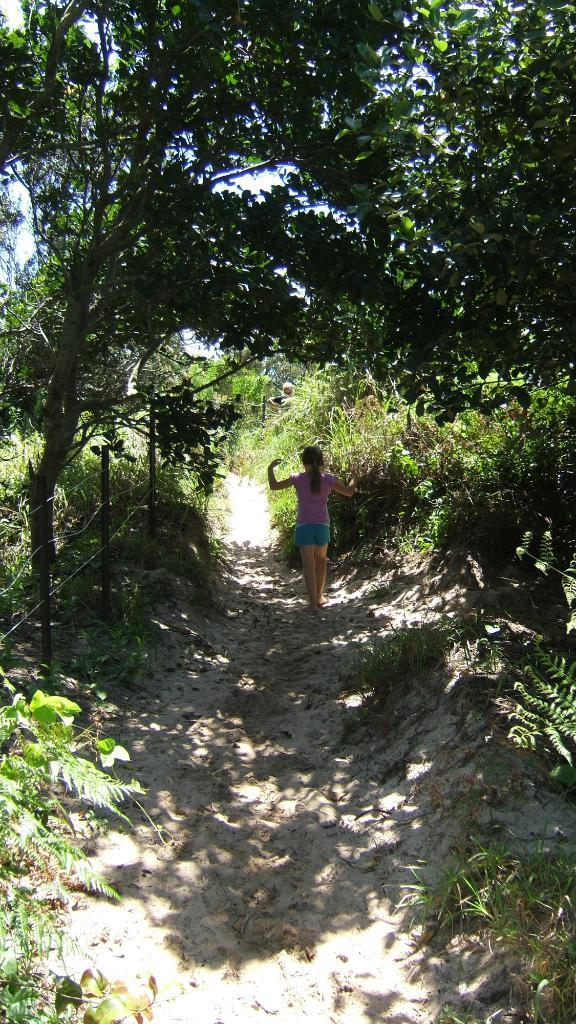What is the girl doing in the image? The girl is standing on the path in the image. What can be seen on the left side of the image? There is a fence on the left side of the image. What is located behind the fence? There are plants and trees behind the fence. What is present on the right side of the image? There are plants on the land on the right side of the image. What type of yak can be seen grazing on the plants in the image? There is no yak present in the image; it features a girl standing on a path with plants and trees in the background. 